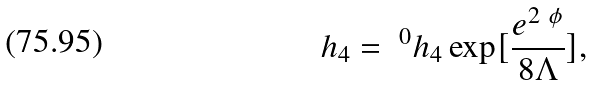<formula> <loc_0><loc_0><loc_500><loc_500>h _ { 4 } = \ ^ { 0 } h _ { 4 } \exp [ \frac { e ^ { 2 \ \phi } } { 8 \Lambda } ] ,</formula> 